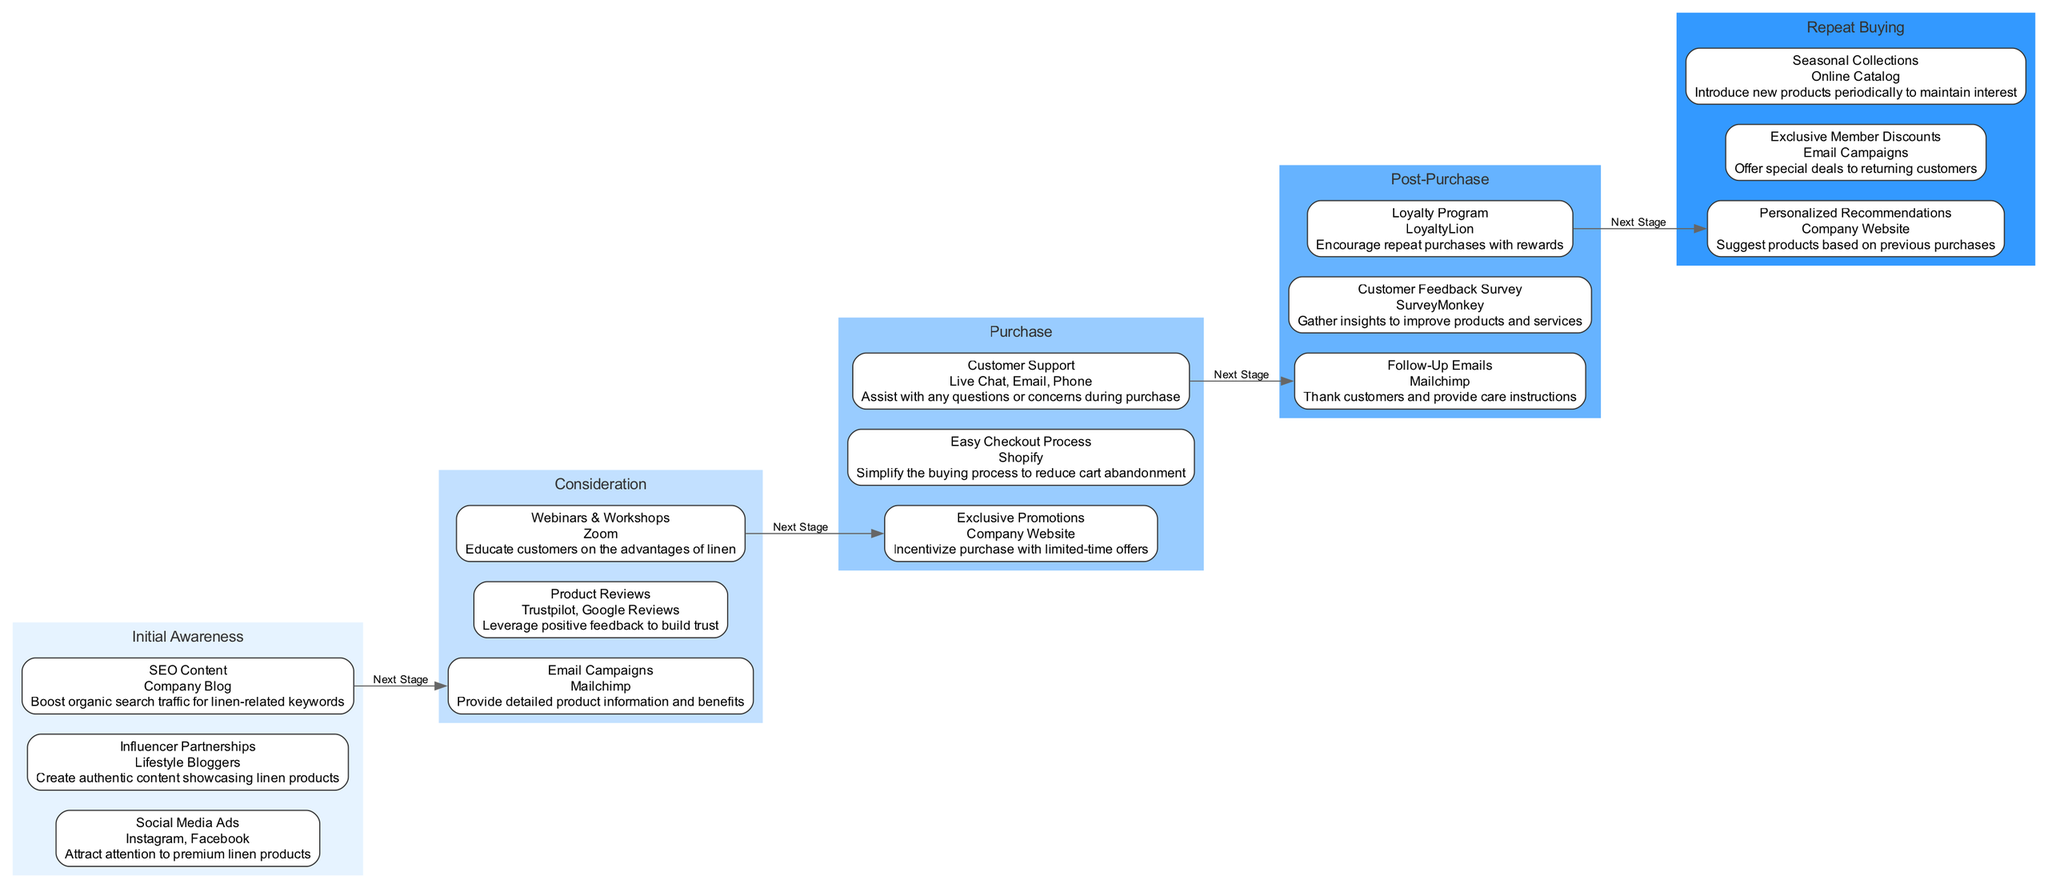What are the three actions in the Initial Awareness stage? The diagram lists three actions under the Initial Awareness stage: Social Media Ads, Influencer Partnerships, and SEO Content.
Answer: Social Media Ads, Influencer Partnerships, SEO Content How many elements are in the Consideration stage? The Consideration stage has three elements: Email Campaigns, Product Reviews, and Webinars & Workshops. Counting them gives a total of three.
Answer: 3 What is the primary goal of Exclusive Promotions? According to the diagram, the goal of Exclusive Promotions is to incentivize purchase with limited-time offers.
Answer: Incentivize purchase with limited-time offers What is the last action before Post-Purchase? The last action listed in the Purchase stage, which transitions to Post-Purchase, is Customer Support.
Answer: Customer Support Which platform is used for Follow-Up Emails? The diagram specifies that Follow-Up Emails are conducted through Mailchimp.
Answer: Mailchimp In what stage is the Loyalty Program found? The Loyalty Program is listed in the Post-Purchase stage, indicating its role after the purchase has been made.
Answer: Post-Purchase What links the Purchase stage to Repeat Buying? The diagram shows that the action from the Purchase stage leading into Repeat Buying is represented as "Next Stage". This transitions through Customer Support to Personalized Recommendations.
Answer: Next Stage Which stage includes Webinars & Workshops? Upon examining the diagram, it can be noted that Webinars & Workshops are part of the Consideration stage.
Answer: Consideration How many stages are in the customer journey? The diagram outlines a total of five stages: Initial Awareness, Consideration, Purchase, Post-Purchase, and Repeat Buying. This sums up to five separate stages.
Answer: 5 